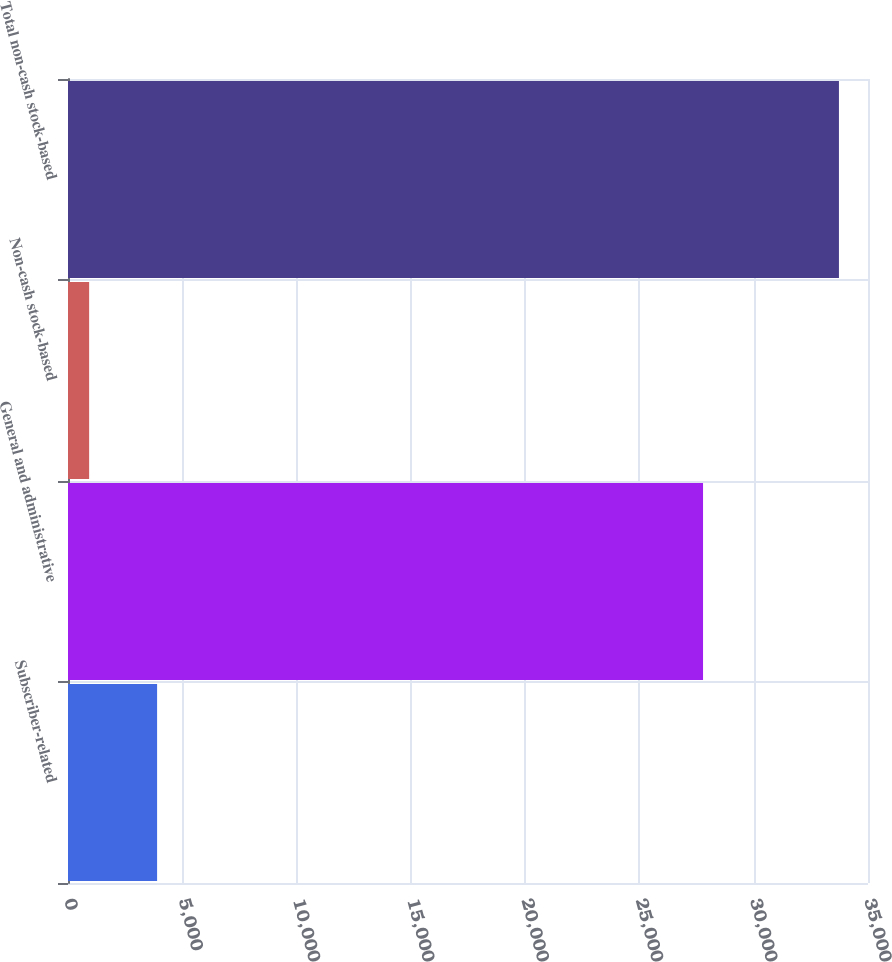Convert chart. <chart><loc_0><loc_0><loc_500><loc_500><bar_chart><fcel>Subscriber-related<fcel>General and administrative<fcel>Non-cash stock-based<fcel>Total non-cash stock-based<nl><fcel>3898<fcel>27783<fcel>925<fcel>33729<nl></chart> 